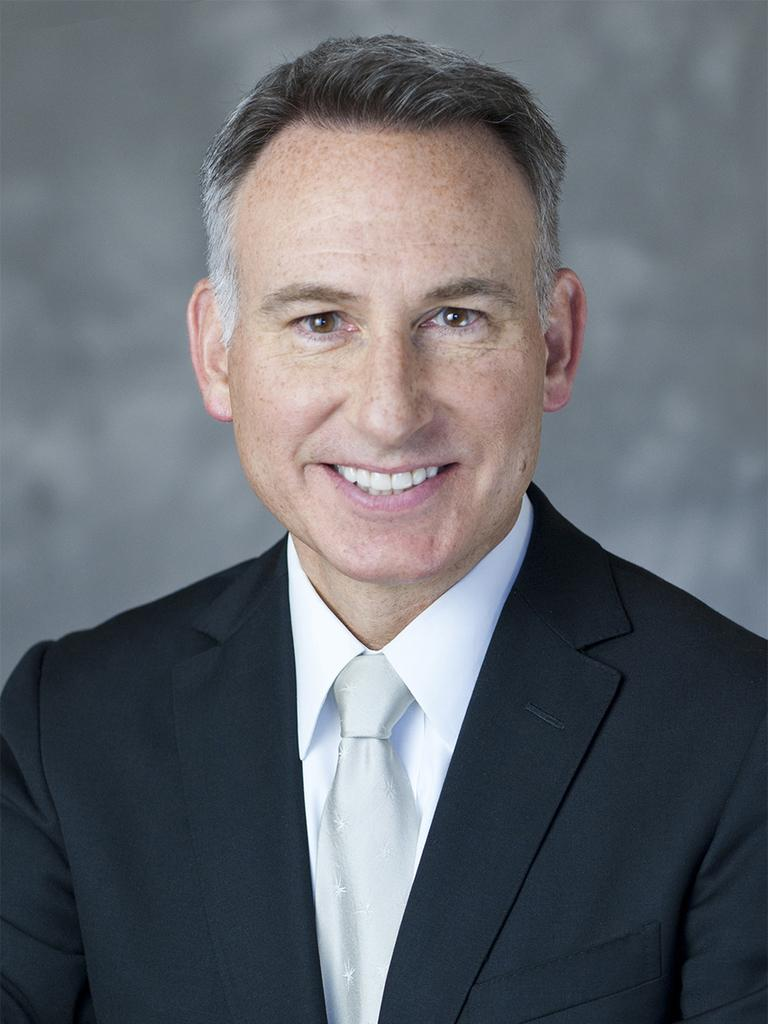What is present in the image? There is a person in the image. How is the person's expression in the image? The person is smiling. What is the price of the toys in the image? There are no toys present in the image, so it is not possible to determine their price. 